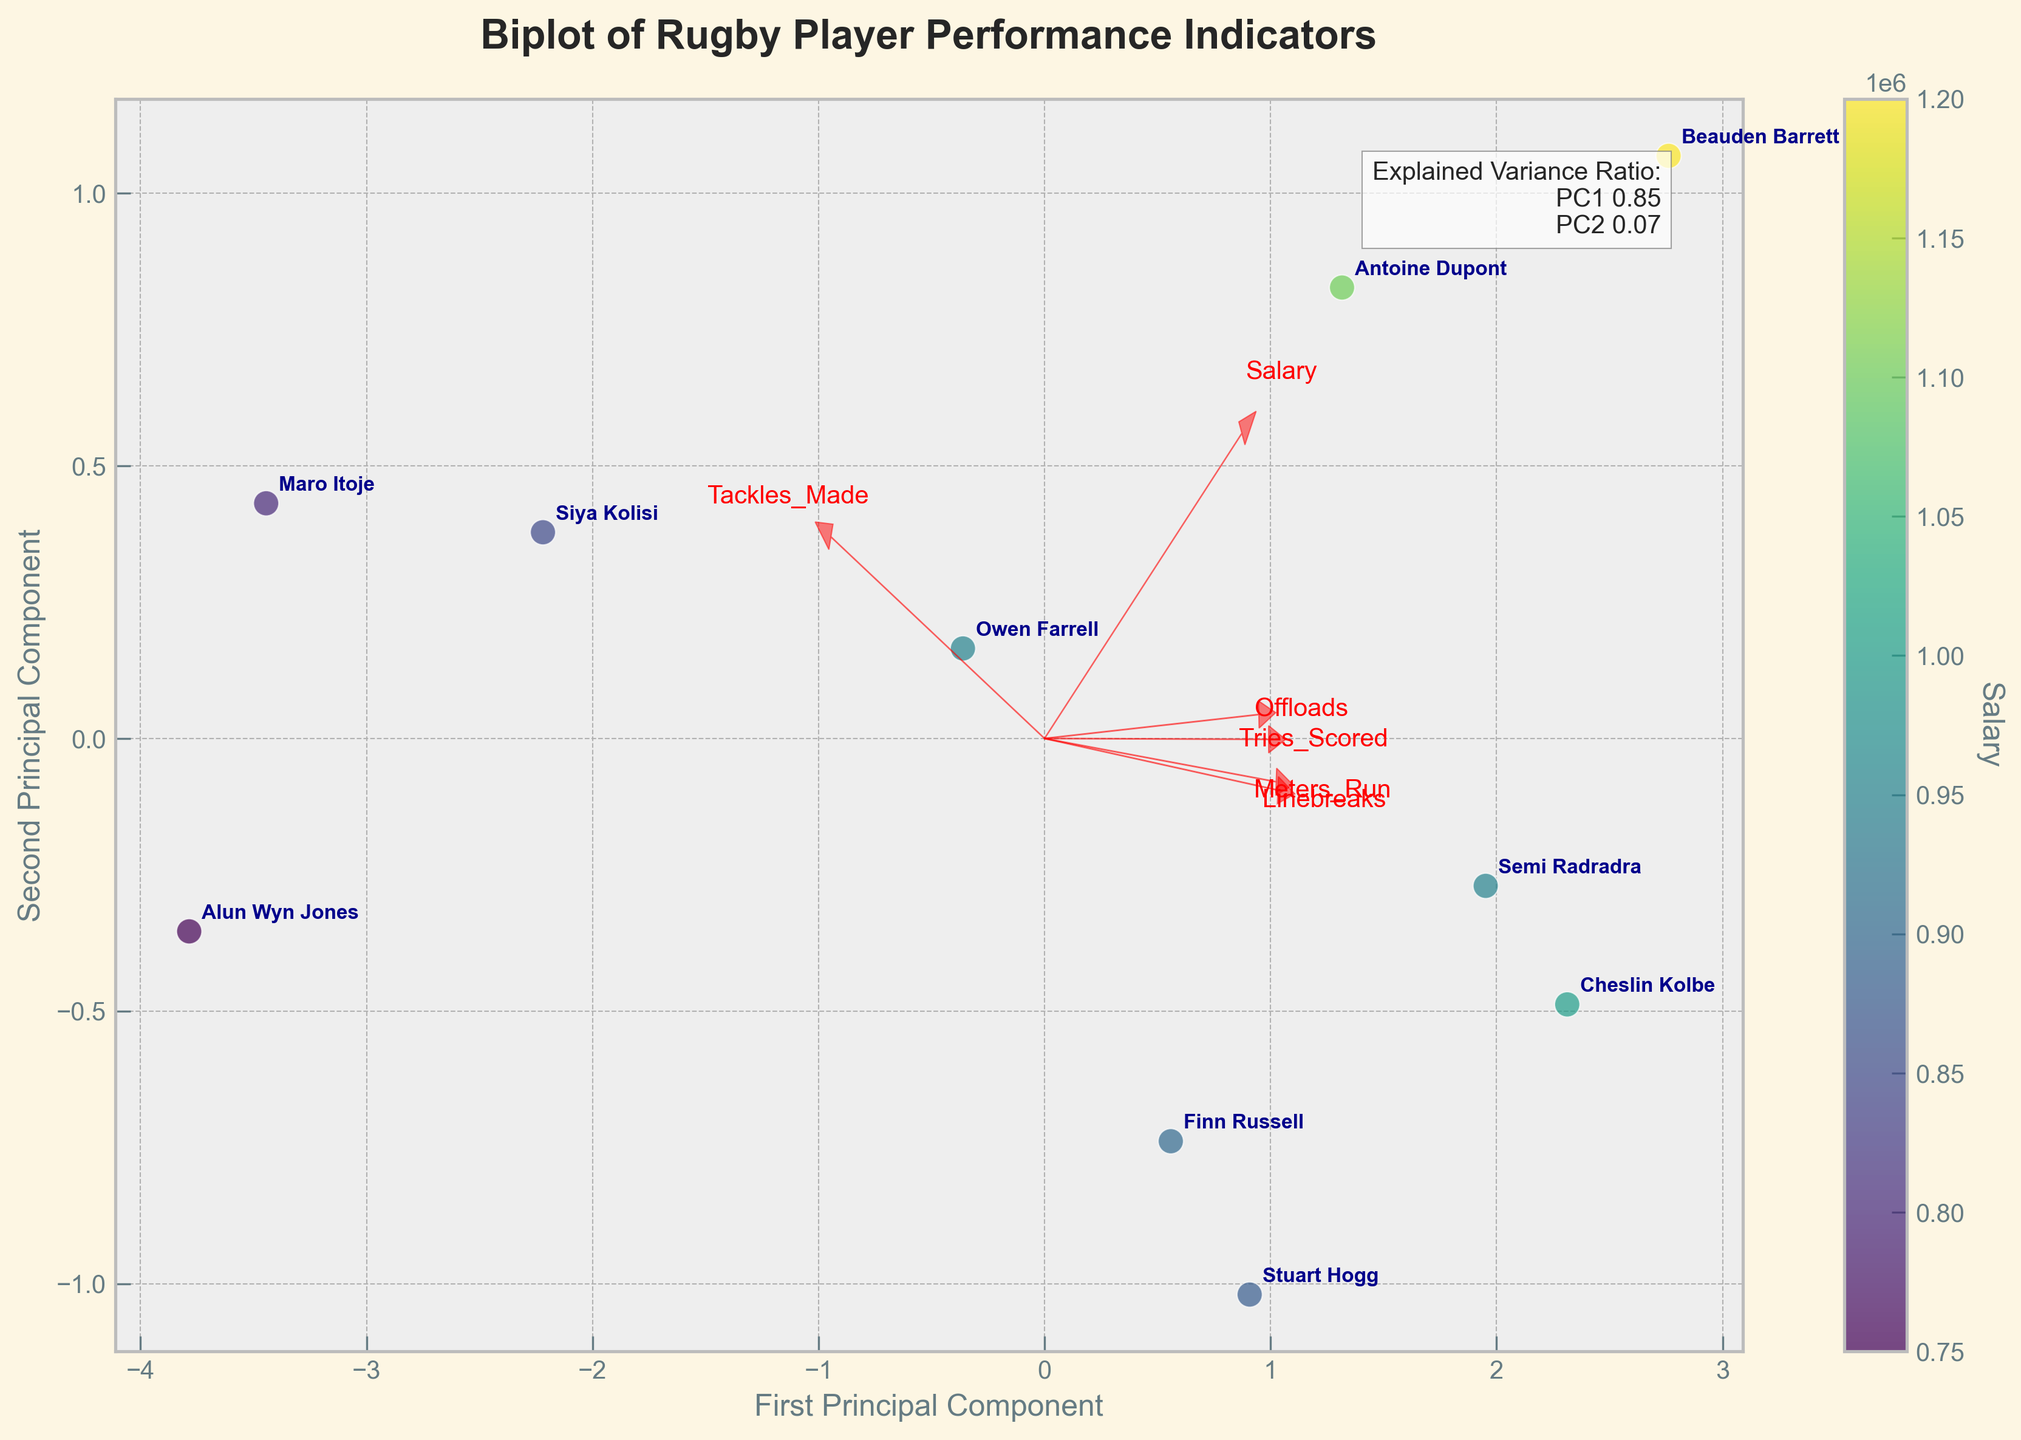What's the title of the plot? The title is typically at the top of the plot, displayed in larger and bold font style. It provides an overview of what the plot represents.
Answer: Biplot of Rugby Player Performance Indicators What do the arrows represent on the plot? The arrows in a biplot represent the loadings of the original variables on the principal components. The direction and length of the arrows indicate the contribution of each variable to the principal components.
Answer: The contribution of performance indicators Which player has the highest salary? The player with the highest salary would be represented by the data point with the highest color value on the color scale of the plot.
Answer: Beauden Barrett What are the axes labeled as? The labels of the axes, typically towards the sides of the plot, indicate what the principal components are. In this case, it provides information on the axes labels.
Answer: First Principal Component and Second Principal Component How many players have been plotted on the biplot? Counting the number of distinct data points or labels corresponding to player names on the plot determines the number of plotted players.
Answer: 10 Which performance indicator seems to contribute most to the first principal component? The performance indicator whose arrow is longest in the direction of the first principal component (x-axis) has the most significant contribution.
Answer: Salary Which player is closest to the loading vector for 'Offloads'? By visually checking the position of the player's data points near the 'Offloads' arrow, the player closest to this arrow can be determined.
Answer: Semi Radradra Which two players appear to have similar performance profiles on the plot? Players that are located close to each other on the plot are likely to have similar performance profiles in terms of the principal components.
Answer: Antoine Dupont and Finn Russell What does the color of each data point represent? The color of each point is related to the value of another variable, which can be deduced from the color bar legend next to the plot.
Answer: Salary Do the explained variance ratios for the first two principal components add up to 1? The explained variance ratios information is usually given as text on the plot. Checking their sum helps understand the fraction of total variance explained by these components.
Answer: No 